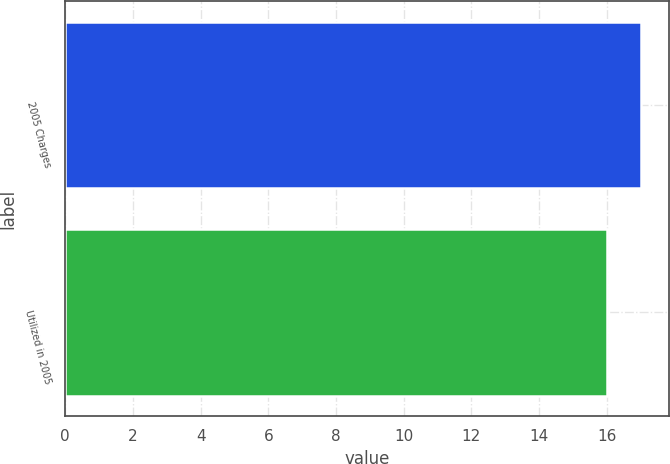<chart> <loc_0><loc_0><loc_500><loc_500><bar_chart><fcel>2005 Charges<fcel>Utilized in 2005<nl><fcel>17<fcel>16<nl></chart> 